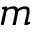<formula> <loc_0><loc_0><loc_500><loc_500>m</formula> 